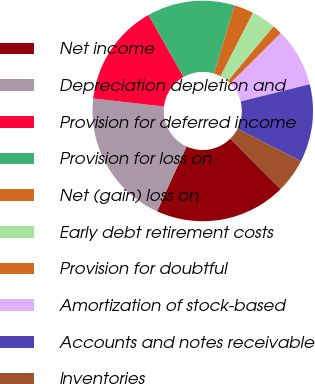Convert chart. <chart><loc_0><loc_0><loc_500><loc_500><pie_chart><fcel>Net income<fcel>Depreciation depletion and<fcel>Provision for deferred income<fcel>Provision for loss on<fcel>Net (gain) loss on<fcel>Early debt retirement costs<fcel>Provision for doubtful<fcel>Amortization of stock-based<fcel>Accounts and notes receivable<fcel>Inventories<nl><fcel>19.28%<fcel>20.0%<fcel>15.0%<fcel>12.86%<fcel>2.86%<fcel>3.57%<fcel>1.43%<fcel>8.57%<fcel>11.43%<fcel>5.0%<nl></chart> 